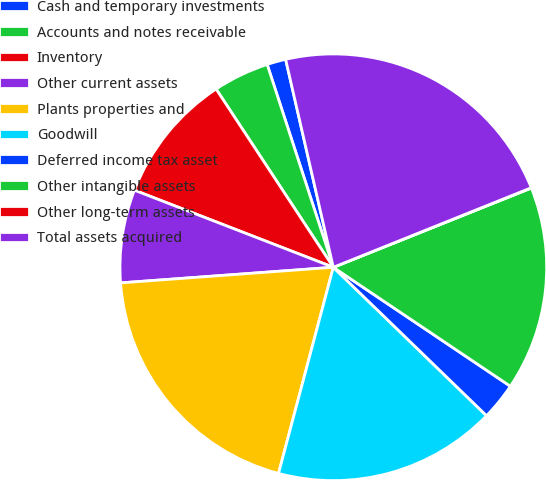Convert chart. <chart><loc_0><loc_0><loc_500><loc_500><pie_chart><fcel>Cash and temporary investments<fcel>Accounts and notes receivable<fcel>Inventory<fcel>Other current assets<fcel>Plants properties and<fcel>Goodwill<fcel>Deferred income tax asset<fcel>Other intangible assets<fcel>Other long-term assets<fcel>Total assets acquired<nl><fcel>1.43%<fcel>4.24%<fcel>9.86%<fcel>7.05%<fcel>19.7%<fcel>16.89%<fcel>2.83%<fcel>15.48%<fcel>0.02%<fcel>22.51%<nl></chart> 